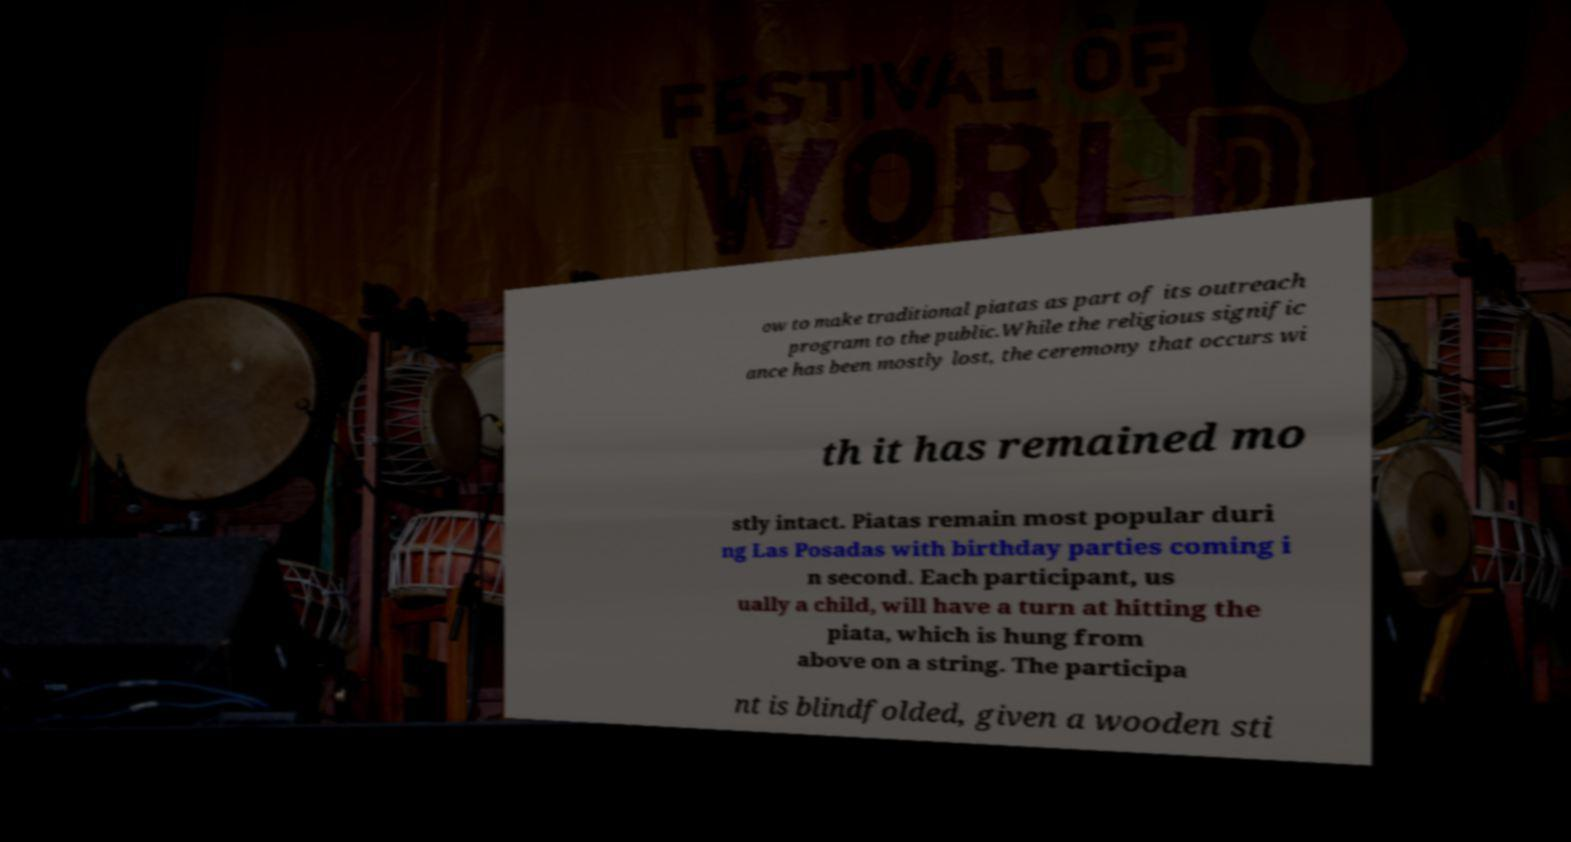Can you read and provide the text displayed in the image?This photo seems to have some interesting text. Can you extract and type it out for me? ow to make traditional piatas as part of its outreach program to the public.While the religious signific ance has been mostly lost, the ceremony that occurs wi th it has remained mo stly intact. Piatas remain most popular duri ng Las Posadas with birthday parties coming i n second. Each participant, us ually a child, will have a turn at hitting the piata, which is hung from above on a string. The participa nt is blindfolded, given a wooden sti 